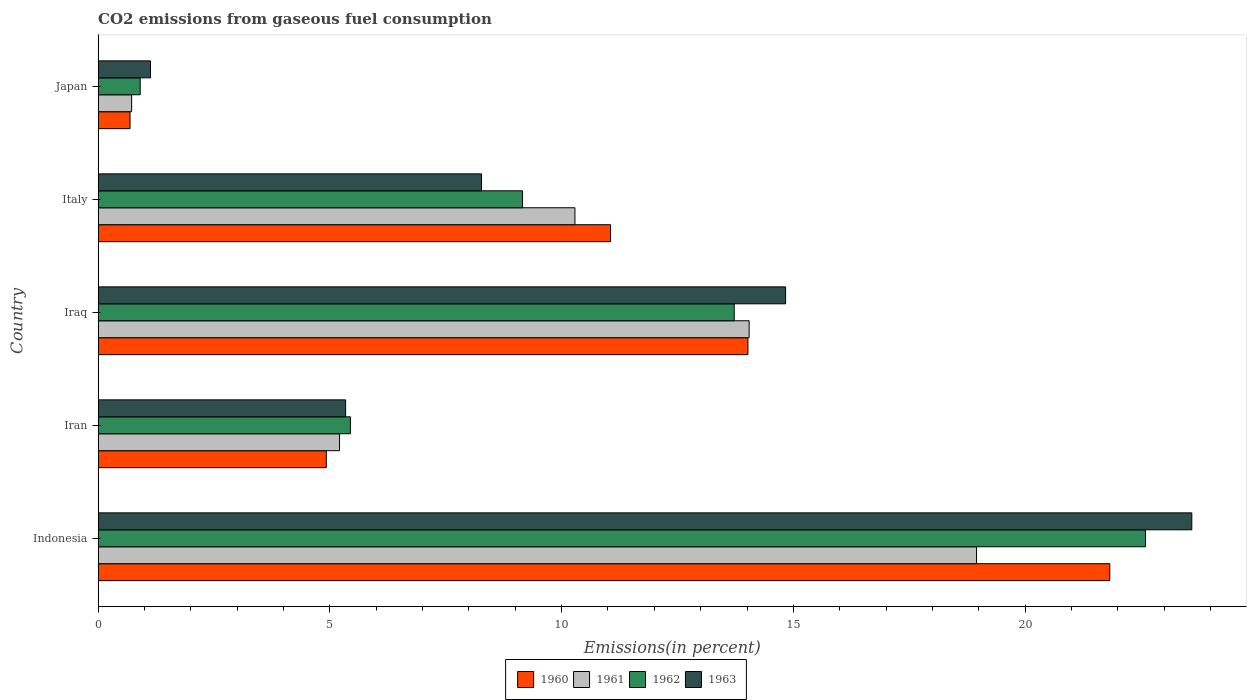Are the number of bars per tick equal to the number of legend labels?
Your answer should be compact. Yes. Are the number of bars on each tick of the Y-axis equal?
Your response must be concise. Yes. How many bars are there on the 5th tick from the bottom?
Provide a short and direct response. 4. In how many cases, is the number of bars for a given country not equal to the number of legend labels?
Provide a succinct answer. 0. What is the total CO2 emitted in 1962 in Indonesia?
Give a very brief answer. 22.6. Across all countries, what is the maximum total CO2 emitted in 1960?
Provide a short and direct response. 21.83. Across all countries, what is the minimum total CO2 emitted in 1962?
Make the answer very short. 0.91. In which country was the total CO2 emitted in 1963 minimum?
Your answer should be compact. Japan. What is the total total CO2 emitted in 1961 in the graph?
Ensure brevity in your answer.  49.22. What is the difference between the total CO2 emitted in 1960 in Indonesia and that in Italy?
Provide a succinct answer. 10.77. What is the difference between the total CO2 emitted in 1961 in Japan and the total CO2 emitted in 1963 in Italy?
Give a very brief answer. -7.55. What is the average total CO2 emitted in 1963 per country?
Give a very brief answer. 10.63. What is the difference between the total CO2 emitted in 1961 and total CO2 emitted in 1960 in Japan?
Your response must be concise. 0.03. In how many countries, is the total CO2 emitted in 1962 greater than 22 %?
Give a very brief answer. 1. What is the ratio of the total CO2 emitted in 1963 in Indonesia to that in Japan?
Ensure brevity in your answer.  20.89. What is the difference between the highest and the second highest total CO2 emitted in 1960?
Your answer should be compact. 7.81. What is the difference between the highest and the lowest total CO2 emitted in 1961?
Offer a very short reply. 18.23. Is the sum of the total CO2 emitted in 1960 in Indonesia and Japan greater than the maximum total CO2 emitted in 1961 across all countries?
Keep it short and to the point. Yes. Is it the case that in every country, the sum of the total CO2 emitted in 1961 and total CO2 emitted in 1960 is greater than the sum of total CO2 emitted in 1962 and total CO2 emitted in 1963?
Your response must be concise. No. What does the 4th bar from the top in Iran represents?
Make the answer very short. 1960. How many bars are there?
Your answer should be compact. 20. Are all the bars in the graph horizontal?
Your response must be concise. Yes. How many countries are there in the graph?
Offer a very short reply. 5. Are the values on the major ticks of X-axis written in scientific E-notation?
Ensure brevity in your answer.  No. Does the graph contain any zero values?
Offer a terse response. No. How many legend labels are there?
Ensure brevity in your answer.  4. How are the legend labels stacked?
Your answer should be very brief. Horizontal. What is the title of the graph?
Make the answer very short. CO2 emissions from gaseous fuel consumption. What is the label or title of the X-axis?
Provide a succinct answer. Emissions(in percent). What is the Emissions(in percent) in 1960 in Indonesia?
Provide a succinct answer. 21.83. What is the Emissions(in percent) of 1961 in Indonesia?
Ensure brevity in your answer.  18.95. What is the Emissions(in percent) in 1962 in Indonesia?
Ensure brevity in your answer.  22.6. What is the Emissions(in percent) in 1963 in Indonesia?
Your answer should be compact. 23.6. What is the Emissions(in percent) in 1960 in Iran?
Your answer should be very brief. 4.92. What is the Emissions(in percent) in 1961 in Iran?
Your response must be concise. 5.21. What is the Emissions(in percent) of 1962 in Iran?
Your response must be concise. 5.44. What is the Emissions(in percent) in 1963 in Iran?
Keep it short and to the point. 5.34. What is the Emissions(in percent) in 1960 in Iraq?
Offer a very short reply. 14.02. What is the Emissions(in percent) in 1961 in Iraq?
Provide a short and direct response. 14.05. What is the Emissions(in percent) of 1962 in Iraq?
Offer a very short reply. 13.72. What is the Emissions(in percent) in 1963 in Iraq?
Ensure brevity in your answer.  14.83. What is the Emissions(in percent) in 1960 in Italy?
Offer a very short reply. 11.06. What is the Emissions(in percent) of 1961 in Italy?
Offer a terse response. 10.29. What is the Emissions(in percent) of 1962 in Italy?
Give a very brief answer. 9.16. What is the Emissions(in percent) of 1963 in Italy?
Your response must be concise. 8.27. What is the Emissions(in percent) in 1960 in Japan?
Your response must be concise. 0.69. What is the Emissions(in percent) in 1961 in Japan?
Provide a short and direct response. 0.72. What is the Emissions(in percent) in 1962 in Japan?
Your response must be concise. 0.91. What is the Emissions(in percent) in 1963 in Japan?
Make the answer very short. 1.13. Across all countries, what is the maximum Emissions(in percent) in 1960?
Keep it short and to the point. 21.83. Across all countries, what is the maximum Emissions(in percent) in 1961?
Give a very brief answer. 18.95. Across all countries, what is the maximum Emissions(in percent) of 1962?
Make the answer very short. 22.6. Across all countries, what is the maximum Emissions(in percent) of 1963?
Your answer should be very brief. 23.6. Across all countries, what is the minimum Emissions(in percent) of 1960?
Ensure brevity in your answer.  0.69. Across all countries, what is the minimum Emissions(in percent) of 1961?
Keep it short and to the point. 0.72. Across all countries, what is the minimum Emissions(in percent) in 1962?
Offer a very short reply. 0.91. Across all countries, what is the minimum Emissions(in percent) in 1963?
Your response must be concise. 1.13. What is the total Emissions(in percent) in 1960 in the graph?
Offer a terse response. 52.51. What is the total Emissions(in percent) of 1961 in the graph?
Give a very brief answer. 49.22. What is the total Emissions(in percent) in 1962 in the graph?
Your answer should be very brief. 51.83. What is the total Emissions(in percent) of 1963 in the graph?
Offer a very short reply. 53.17. What is the difference between the Emissions(in percent) in 1960 in Indonesia and that in Iran?
Keep it short and to the point. 16.9. What is the difference between the Emissions(in percent) of 1961 in Indonesia and that in Iran?
Provide a succinct answer. 13.74. What is the difference between the Emissions(in percent) of 1962 in Indonesia and that in Iran?
Make the answer very short. 17.15. What is the difference between the Emissions(in percent) in 1963 in Indonesia and that in Iran?
Keep it short and to the point. 18.26. What is the difference between the Emissions(in percent) in 1960 in Indonesia and that in Iraq?
Keep it short and to the point. 7.81. What is the difference between the Emissions(in percent) in 1961 in Indonesia and that in Iraq?
Your response must be concise. 4.91. What is the difference between the Emissions(in percent) of 1962 in Indonesia and that in Iraq?
Provide a short and direct response. 8.87. What is the difference between the Emissions(in percent) of 1963 in Indonesia and that in Iraq?
Provide a short and direct response. 8.76. What is the difference between the Emissions(in percent) in 1960 in Indonesia and that in Italy?
Offer a very short reply. 10.77. What is the difference between the Emissions(in percent) in 1961 in Indonesia and that in Italy?
Your answer should be very brief. 8.66. What is the difference between the Emissions(in percent) in 1962 in Indonesia and that in Italy?
Give a very brief answer. 13.44. What is the difference between the Emissions(in percent) in 1963 in Indonesia and that in Italy?
Your response must be concise. 15.32. What is the difference between the Emissions(in percent) in 1960 in Indonesia and that in Japan?
Give a very brief answer. 21.14. What is the difference between the Emissions(in percent) of 1961 in Indonesia and that in Japan?
Offer a terse response. 18.23. What is the difference between the Emissions(in percent) in 1962 in Indonesia and that in Japan?
Make the answer very short. 21.69. What is the difference between the Emissions(in percent) in 1963 in Indonesia and that in Japan?
Your answer should be very brief. 22.47. What is the difference between the Emissions(in percent) in 1960 in Iran and that in Iraq?
Ensure brevity in your answer.  -9.1. What is the difference between the Emissions(in percent) of 1961 in Iran and that in Iraq?
Ensure brevity in your answer.  -8.84. What is the difference between the Emissions(in percent) in 1962 in Iran and that in Iraq?
Your response must be concise. -8.28. What is the difference between the Emissions(in percent) in 1963 in Iran and that in Iraq?
Keep it short and to the point. -9.49. What is the difference between the Emissions(in percent) in 1960 in Iran and that in Italy?
Keep it short and to the point. -6.13. What is the difference between the Emissions(in percent) of 1961 in Iran and that in Italy?
Your answer should be compact. -5.08. What is the difference between the Emissions(in percent) in 1962 in Iran and that in Italy?
Provide a succinct answer. -3.71. What is the difference between the Emissions(in percent) in 1963 in Iran and that in Italy?
Give a very brief answer. -2.93. What is the difference between the Emissions(in percent) of 1960 in Iran and that in Japan?
Your answer should be very brief. 4.23. What is the difference between the Emissions(in percent) of 1961 in Iran and that in Japan?
Provide a short and direct response. 4.49. What is the difference between the Emissions(in percent) of 1962 in Iran and that in Japan?
Ensure brevity in your answer.  4.53. What is the difference between the Emissions(in percent) of 1963 in Iran and that in Japan?
Provide a succinct answer. 4.21. What is the difference between the Emissions(in percent) in 1960 in Iraq and that in Italy?
Offer a very short reply. 2.96. What is the difference between the Emissions(in percent) in 1961 in Iraq and that in Italy?
Keep it short and to the point. 3.76. What is the difference between the Emissions(in percent) of 1962 in Iraq and that in Italy?
Your response must be concise. 4.57. What is the difference between the Emissions(in percent) of 1963 in Iraq and that in Italy?
Offer a terse response. 6.56. What is the difference between the Emissions(in percent) in 1960 in Iraq and that in Japan?
Your answer should be very brief. 13.33. What is the difference between the Emissions(in percent) of 1961 in Iraq and that in Japan?
Your answer should be compact. 13.32. What is the difference between the Emissions(in percent) in 1962 in Iraq and that in Japan?
Make the answer very short. 12.82. What is the difference between the Emissions(in percent) in 1963 in Iraq and that in Japan?
Make the answer very short. 13.7. What is the difference between the Emissions(in percent) of 1960 in Italy and that in Japan?
Your answer should be compact. 10.37. What is the difference between the Emissions(in percent) in 1961 in Italy and that in Japan?
Provide a short and direct response. 9.56. What is the difference between the Emissions(in percent) in 1962 in Italy and that in Japan?
Offer a very short reply. 8.25. What is the difference between the Emissions(in percent) of 1963 in Italy and that in Japan?
Offer a terse response. 7.14. What is the difference between the Emissions(in percent) in 1960 in Indonesia and the Emissions(in percent) in 1961 in Iran?
Your response must be concise. 16.62. What is the difference between the Emissions(in percent) of 1960 in Indonesia and the Emissions(in percent) of 1962 in Iran?
Your response must be concise. 16.38. What is the difference between the Emissions(in percent) of 1960 in Indonesia and the Emissions(in percent) of 1963 in Iran?
Ensure brevity in your answer.  16.49. What is the difference between the Emissions(in percent) of 1961 in Indonesia and the Emissions(in percent) of 1962 in Iran?
Your answer should be very brief. 13.51. What is the difference between the Emissions(in percent) in 1961 in Indonesia and the Emissions(in percent) in 1963 in Iran?
Provide a succinct answer. 13.61. What is the difference between the Emissions(in percent) in 1962 in Indonesia and the Emissions(in percent) in 1963 in Iran?
Your response must be concise. 17.26. What is the difference between the Emissions(in percent) of 1960 in Indonesia and the Emissions(in percent) of 1961 in Iraq?
Keep it short and to the point. 7.78. What is the difference between the Emissions(in percent) in 1960 in Indonesia and the Emissions(in percent) in 1962 in Iraq?
Provide a succinct answer. 8.1. What is the difference between the Emissions(in percent) of 1960 in Indonesia and the Emissions(in percent) of 1963 in Iraq?
Make the answer very short. 6.99. What is the difference between the Emissions(in percent) in 1961 in Indonesia and the Emissions(in percent) in 1962 in Iraq?
Your answer should be very brief. 5.23. What is the difference between the Emissions(in percent) in 1961 in Indonesia and the Emissions(in percent) in 1963 in Iraq?
Your response must be concise. 4.12. What is the difference between the Emissions(in percent) in 1962 in Indonesia and the Emissions(in percent) in 1963 in Iraq?
Provide a short and direct response. 7.76. What is the difference between the Emissions(in percent) of 1960 in Indonesia and the Emissions(in percent) of 1961 in Italy?
Offer a terse response. 11.54. What is the difference between the Emissions(in percent) of 1960 in Indonesia and the Emissions(in percent) of 1962 in Italy?
Give a very brief answer. 12.67. What is the difference between the Emissions(in percent) in 1960 in Indonesia and the Emissions(in percent) in 1963 in Italy?
Your answer should be compact. 13.55. What is the difference between the Emissions(in percent) of 1961 in Indonesia and the Emissions(in percent) of 1962 in Italy?
Keep it short and to the point. 9.8. What is the difference between the Emissions(in percent) in 1961 in Indonesia and the Emissions(in percent) in 1963 in Italy?
Offer a terse response. 10.68. What is the difference between the Emissions(in percent) in 1962 in Indonesia and the Emissions(in percent) in 1963 in Italy?
Your answer should be very brief. 14.32. What is the difference between the Emissions(in percent) in 1960 in Indonesia and the Emissions(in percent) in 1961 in Japan?
Provide a succinct answer. 21.1. What is the difference between the Emissions(in percent) in 1960 in Indonesia and the Emissions(in percent) in 1962 in Japan?
Offer a very short reply. 20.92. What is the difference between the Emissions(in percent) of 1960 in Indonesia and the Emissions(in percent) of 1963 in Japan?
Your answer should be very brief. 20.7. What is the difference between the Emissions(in percent) in 1961 in Indonesia and the Emissions(in percent) in 1962 in Japan?
Give a very brief answer. 18.04. What is the difference between the Emissions(in percent) of 1961 in Indonesia and the Emissions(in percent) of 1963 in Japan?
Give a very brief answer. 17.82. What is the difference between the Emissions(in percent) in 1962 in Indonesia and the Emissions(in percent) in 1963 in Japan?
Your response must be concise. 21.47. What is the difference between the Emissions(in percent) in 1960 in Iran and the Emissions(in percent) in 1961 in Iraq?
Offer a terse response. -9.12. What is the difference between the Emissions(in percent) in 1960 in Iran and the Emissions(in percent) in 1962 in Iraq?
Your response must be concise. -8.8. What is the difference between the Emissions(in percent) in 1960 in Iran and the Emissions(in percent) in 1963 in Iraq?
Give a very brief answer. -9.91. What is the difference between the Emissions(in percent) of 1961 in Iran and the Emissions(in percent) of 1962 in Iraq?
Your response must be concise. -8.51. What is the difference between the Emissions(in percent) in 1961 in Iran and the Emissions(in percent) in 1963 in Iraq?
Keep it short and to the point. -9.62. What is the difference between the Emissions(in percent) in 1962 in Iran and the Emissions(in percent) in 1963 in Iraq?
Offer a terse response. -9.39. What is the difference between the Emissions(in percent) in 1960 in Iran and the Emissions(in percent) in 1961 in Italy?
Your answer should be compact. -5.36. What is the difference between the Emissions(in percent) of 1960 in Iran and the Emissions(in percent) of 1962 in Italy?
Your answer should be compact. -4.23. What is the difference between the Emissions(in percent) of 1960 in Iran and the Emissions(in percent) of 1963 in Italy?
Make the answer very short. -3.35. What is the difference between the Emissions(in percent) of 1961 in Iran and the Emissions(in percent) of 1962 in Italy?
Ensure brevity in your answer.  -3.95. What is the difference between the Emissions(in percent) of 1961 in Iran and the Emissions(in percent) of 1963 in Italy?
Ensure brevity in your answer.  -3.06. What is the difference between the Emissions(in percent) in 1962 in Iran and the Emissions(in percent) in 1963 in Italy?
Give a very brief answer. -2.83. What is the difference between the Emissions(in percent) of 1960 in Iran and the Emissions(in percent) of 1961 in Japan?
Provide a succinct answer. 4.2. What is the difference between the Emissions(in percent) of 1960 in Iran and the Emissions(in percent) of 1962 in Japan?
Ensure brevity in your answer.  4.02. What is the difference between the Emissions(in percent) in 1960 in Iran and the Emissions(in percent) in 1963 in Japan?
Your answer should be compact. 3.79. What is the difference between the Emissions(in percent) in 1961 in Iran and the Emissions(in percent) in 1962 in Japan?
Ensure brevity in your answer.  4.3. What is the difference between the Emissions(in percent) in 1961 in Iran and the Emissions(in percent) in 1963 in Japan?
Provide a short and direct response. 4.08. What is the difference between the Emissions(in percent) of 1962 in Iran and the Emissions(in percent) of 1963 in Japan?
Keep it short and to the point. 4.31. What is the difference between the Emissions(in percent) in 1960 in Iraq and the Emissions(in percent) in 1961 in Italy?
Give a very brief answer. 3.73. What is the difference between the Emissions(in percent) in 1960 in Iraq and the Emissions(in percent) in 1962 in Italy?
Keep it short and to the point. 4.86. What is the difference between the Emissions(in percent) in 1960 in Iraq and the Emissions(in percent) in 1963 in Italy?
Give a very brief answer. 5.75. What is the difference between the Emissions(in percent) in 1961 in Iraq and the Emissions(in percent) in 1962 in Italy?
Your answer should be compact. 4.89. What is the difference between the Emissions(in percent) in 1961 in Iraq and the Emissions(in percent) in 1963 in Italy?
Ensure brevity in your answer.  5.77. What is the difference between the Emissions(in percent) in 1962 in Iraq and the Emissions(in percent) in 1963 in Italy?
Give a very brief answer. 5.45. What is the difference between the Emissions(in percent) in 1960 in Iraq and the Emissions(in percent) in 1961 in Japan?
Ensure brevity in your answer.  13.3. What is the difference between the Emissions(in percent) of 1960 in Iraq and the Emissions(in percent) of 1962 in Japan?
Your answer should be very brief. 13.11. What is the difference between the Emissions(in percent) of 1960 in Iraq and the Emissions(in percent) of 1963 in Japan?
Make the answer very short. 12.89. What is the difference between the Emissions(in percent) in 1961 in Iraq and the Emissions(in percent) in 1962 in Japan?
Give a very brief answer. 13.14. What is the difference between the Emissions(in percent) of 1961 in Iraq and the Emissions(in percent) of 1963 in Japan?
Make the answer very short. 12.92. What is the difference between the Emissions(in percent) of 1962 in Iraq and the Emissions(in percent) of 1963 in Japan?
Your response must be concise. 12.59. What is the difference between the Emissions(in percent) in 1960 in Italy and the Emissions(in percent) in 1961 in Japan?
Provide a succinct answer. 10.33. What is the difference between the Emissions(in percent) of 1960 in Italy and the Emissions(in percent) of 1962 in Japan?
Your response must be concise. 10.15. What is the difference between the Emissions(in percent) of 1960 in Italy and the Emissions(in percent) of 1963 in Japan?
Your answer should be very brief. 9.93. What is the difference between the Emissions(in percent) of 1961 in Italy and the Emissions(in percent) of 1962 in Japan?
Your response must be concise. 9.38. What is the difference between the Emissions(in percent) of 1961 in Italy and the Emissions(in percent) of 1963 in Japan?
Provide a short and direct response. 9.16. What is the difference between the Emissions(in percent) in 1962 in Italy and the Emissions(in percent) in 1963 in Japan?
Your answer should be very brief. 8.03. What is the average Emissions(in percent) in 1960 per country?
Your answer should be very brief. 10.5. What is the average Emissions(in percent) in 1961 per country?
Provide a succinct answer. 9.84. What is the average Emissions(in percent) in 1962 per country?
Provide a short and direct response. 10.37. What is the average Emissions(in percent) in 1963 per country?
Provide a short and direct response. 10.63. What is the difference between the Emissions(in percent) in 1960 and Emissions(in percent) in 1961 in Indonesia?
Your response must be concise. 2.87. What is the difference between the Emissions(in percent) in 1960 and Emissions(in percent) in 1962 in Indonesia?
Your response must be concise. -0.77. What is the difference between the Emissions(in percent) of 1960 and Emissions(in percent) of 1963 in Indonesia?
Offer a terse response. -1.77. What is the difference between the Emissions(in percent) of 1961 and Emissions(in percent) of 1962 in Indonesia?
Your response must be concise. -3.64. What is the difference between the Emissions(in percent) in 1961 and Emissions(in percent) in 1963 in Indonesia?
Give a very brief answer. -4.64. What is the difference between the Emissions(in percent) of 1962 and Emissions(in percent) of 1963 in Indonesia?
Offer a very short reply. -1. What is the difference between the Emissions(in percent) of 1960 and Emissions(in percent) of 1961 in Iran?
Keep it short and to the point. -0.29. What is the difference between the Emissions(in percent) in 1960 and Emissions(in percent) in 1962 in Iran?
Your answer should be very brief. -0.52. What is the difference between the Emissions(in percent) of 1960 and Emissions(in percent) of 1963 in Iran?
Offer a very short reply. -0.42. What is the difference between the Emissions(in percent) of 1961 and Emissions(in percent) of 1962 in Iran?
Offer a terse response. -0.23. What is the difference between the Emissions(in percent) of 1961 and Emissions(in percent) of 1963 in Iran?
Provide a succinct answer. -0.13. What is the difference between the Emissions(in percent) of 1962 and Emissions(in percent) of 1963 in Iran?
Ensure brevity in your answer.  0.1. What is the difference between the Emissions(in percent) in 1960 and Emissions(in percent) in 1961 in Iraq?
Make the answer very short. -0.03. What is the difference between the Emissions(in percent) in 1960 and Emissions(in percent) in 1962 in Iraq?
Your answer should be very brief. 0.3. What is the difference between the Emissions(in percent) in 1960 and Emissions(in percent) in 1963 in Iraq?
Your answer should be compact. -0.81. What is the difference between the Emissions(in percent) of 1961 and Emissions(in percent) of 1962 in Iraq?
Your answer should be compact. 0.32. What is the difference between the Emissions(in percent) of 1961 and Emissions(in percent) of 1963 in Iraq?
Ensure brevity in your answer.  -0.79. What is the difference between the Emissions(in percent) in 1962 and Emissions(in percent) in 1963 in Iraq?
Ensure brevity in your answer.  -1.11. What is the difference between the Emissions(in percent) in 1960 and Emissions(in percent) in 1961 in Italy?
Provide a short and direct response. 0.77. What is the difference between the Emissions(in percent) of 1960 and Emissions(in percent) of 1962 in Italy?
Provide a succinct answer. 1.9. What is the difference between the Emissions(in percent) in 1960 and Emissions(in percent) in 1963 in Italy?
Make the answer very short. 2.78. What is the difference between the Emissions(in percent) in 1961 and Emissions(in percent) in 1962 in Italy?
Keep it short and to the point. 1.13. What is the difference between the Emissions(in percent) in 1961 and Emissions(in percent) in 1963 in Italy?
Keep it short and to the point. 2.02. What is the difference between the Emissions(in percent) in 1962 and Emissions(in percent) in 1963 in Italy?
Your answer should be compact. 0.88. What is the difference between the Emissions(in percent) in 1960 and Emissions(in percent) in 1961 in Japan?
Provide a short and direct response. -0.03. What is the difference between the Emissions(in percent) in 1960 and Emissions(in percent) in 1962 in Japan?
Ensure brevity in your answer.  -0.22. What is the difference between the Emissions(in percent) of 1960 and Emissions(in percent) of 1963 in Japan?
Keep it short and to the point. -0.44. What is the difference between the Emissions(in percent) of 1961 and Emissions(in percent) of 1962 in Japan?
Give a very brief answer. -0.19. What is the difference between the Emissions(in percent) in 1961 and Emissions(in percent) in 1963 in Japan?
Your answer should be compact. -0.41. What is the difference between the Emissions(in percent) of 1962 and Emissions(in percent) of 1963 in Japan?
Make the answer very short. -0.22. What is the ratio of the Emissions(in percent) of 1960 in Indonesia to that in Iran?
Provide a succinct answer. 4.43. What is the ratio of the Emissions(in percent) of 1961 in Indonesia to that in Iran?
Offer a very short reply. 3.64. What is the ratio of the Emissions(in percent) of 1962 in Indonesia to that in Iran?
Ensure brevity in your answer.  4.15. What is the ratio of the Emissions(in percent) in 1963 in Indonesia to that in Iran?
Provide a succinct answer. 4.42. What is the ratio of the Emissions(in percent) in 1960 in Indonesia to that in Iraq?
Your response must be concise. 1.56. What is the ratio of the Emissions(in percent) of 1961 in Indonesia to that in Iraq?
Your response must be concise. 1.35. What is the ratio of the Emissions(in percent) in 1962 in Indonesia to that in Iraq?
Offer a terse response. 1.65. What is the ratio of the Emissions(in percent) of 1963 in Indonesia to that in Iraq?
Keep it short and to the point. 1.59. What is the ratio of the Emissions(in percent) in 1960 in Indonesia to that in Italy?
Offer a terse response. 1.97. What is the ratio of the Emissions(in percent) of 1961 in Indonesia to that in Italy?
Ensure brevity in your answer.  1.84. What is the ratio of the Emissions(in percent) in 1962 in Indonesia to that in Italy?
Ensure brevity in your answer.  2.47. What is the ratio of the Emissions(in percent) of 1963 in Indonesia to that in Italy?
Make the answer very short. 2.85. What is the ratio of the Emissions(in percent) of 1960 in Indonesia to that in Japan?
Give a very brief answer. 31.71. What is the ratio of the Emissions(in percent) in 1961 in Indonesia to that in Japan?
Keep it short and to the point. 26.22. What is the ratio of the Emissions(in percent) in 1962 in Indonesia to that in Japan?
Your answer should be very brief. 24.89. What is the ratio of the Emissions(in percent) in 1963 in Indonesia to that in Japan?
Offer a terse response. 20.89. What is the ratio of the Emissions(in percent) of 1960 in Iran to that in Iraq?
Give a very brief answer. 0.35. What is the ratio of the Emissions(in percent) of 1961 in Iran to that in Iraq?
Provide a short and direct response. 0.37. What is the ratio of the Emissions(in percent) of 1962 in Iran to that in Iraq?
Make the answer very short. 0.4. What is the ratio of the Emissions(in percent) in 1963 in Iran to that in Iraq?
Ensure brevity in your answer.  0.36. What is the ratio of the Emissions(in percent) of 1960 in Iran to that in Italy?
Offer a very short reply. 0.45. What is the ratio of the Emissions(in percent) of 1961 in Iran to that in Italy?
Make the answer very short. 0.51. What is the ratio of the Emissions(in percent) of 1962 in Iran to that in Italy?
Provide a short and direct response. 0.59. What is the ratio of the Emissions(in percent) of 1963 in Iran to that in Italy?
Offer a terse response. 0.65. What is the ratio of the Emissions(in percent) in 1960 in Iran to that in Japan?
Offer a terse response. 7.15. What is the ratio of the Emissions(in percent) in 1961 in Iran to that in Japan?
Provide a short and direct response. 7.21. What is the ratio of the Emissions(in percent) in 1962 in Iran to that in Japan?
Provide a succinct answer. 5.99. What is the ratio of the Emissions(in percent) of 1963 in Iran to that in Japan?
Give a very brief answer. 4.73. What is the ratio of the Emissions(in percent) of 1960 in Iraq to that in Italy?
Make the answer very short. 1.27. What is the ratio of the Emissions(in percent) of 1961 in Iraq to that in Italy?
Make the answer very short. 1.37. What is the ratio of the Emissions(in percent) of 1962 in Iraq to that in Italy?
Your answer should be compact. 1.5. What is the ratio of the Emissions(in percent) in 1963 in Iraq to that in Italy?
Offer a terse response. 1.79. What is the ratio of the Emissions(in percent) in 1960 in Iraq to that in Japan?
Make the answer very short. 20.37. What is the ratio of the Emissions(in percent) of 1961 in Iraq to that in Japan?
Make the answer very short. 19.43. What is the ratio of the Emissions(in percent) of 1962 in Iraq to that in Japan?
Provide a succinct answer. 15.11. What is the ratio of the Emissions(in percent) in 1963 in Iraq to that in Japan?
Offer a very short reply. 13.13. What is the ratio of the Emissions(in percent) of 1960 in Italy to that in Japan?
Your answer should be very brief. 16.06. What is the ratio of the Emissions(in percent) of 1961 in Italy to that in Japan?
Your answer should be compact. 14.23. What is the ratio of the Emissions(in percent) of 1962 in Italy to that in Japan?
Provide a short and direct response. 10.09. What is the ratio of the Emissions(in percent) in 1963 in Italy to that in Japan?
Offer a terse response. 7.32. What is the difference between the highest and the second highest Emissions(in percent) in 1960?
Your answer should be compact. 7.81. What is the difference between the highest and the second highest Emissions(in percent) in 1961?
Your response must be concise. 4.91. What is the difference between the highest and the second highest Emissions(in percent) of 1962?
Provide a short and direct response. 8.87. What is the difference between the highest and the second highest Emissions(in percent) of 1963?
Provide a short and direct response. 8.76. What is the difference between the highest and the lowest Emissions(in percent) in 1960?
Provide a short and direct response. 21.14. What is the difference between the highest and the lowest Emissions(in percent) in 1961?
Offer a terse response. 18.23. What is the difference between the highest and the lowest Emissions(in percent) in 1962?
Keep it short and to the point. 21.69. What is the difference between the highest and the lowest Emissions(in percent) of 1963?
Your answer should be compact. 22.47. 